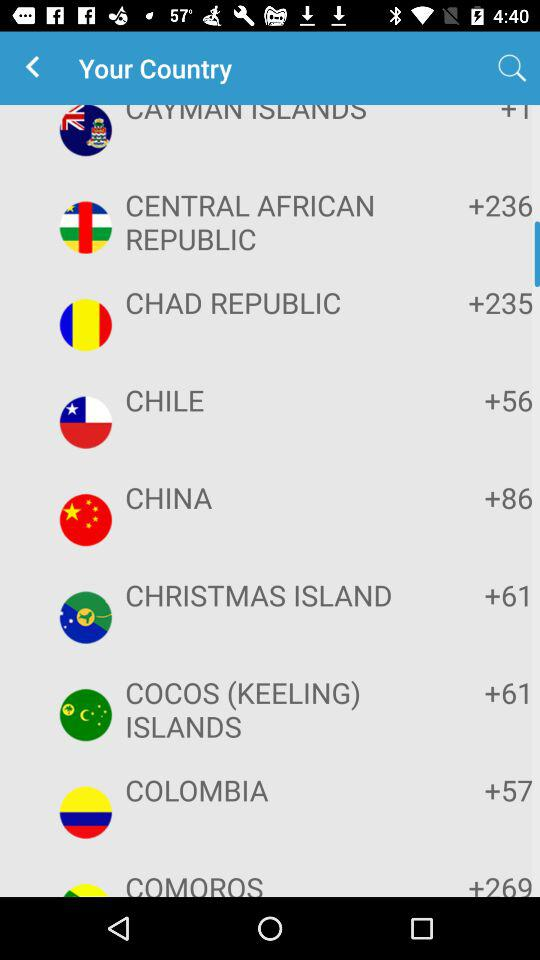What is the country code of the Republic of Chad? The country code of the Republic of Chad is +235. 